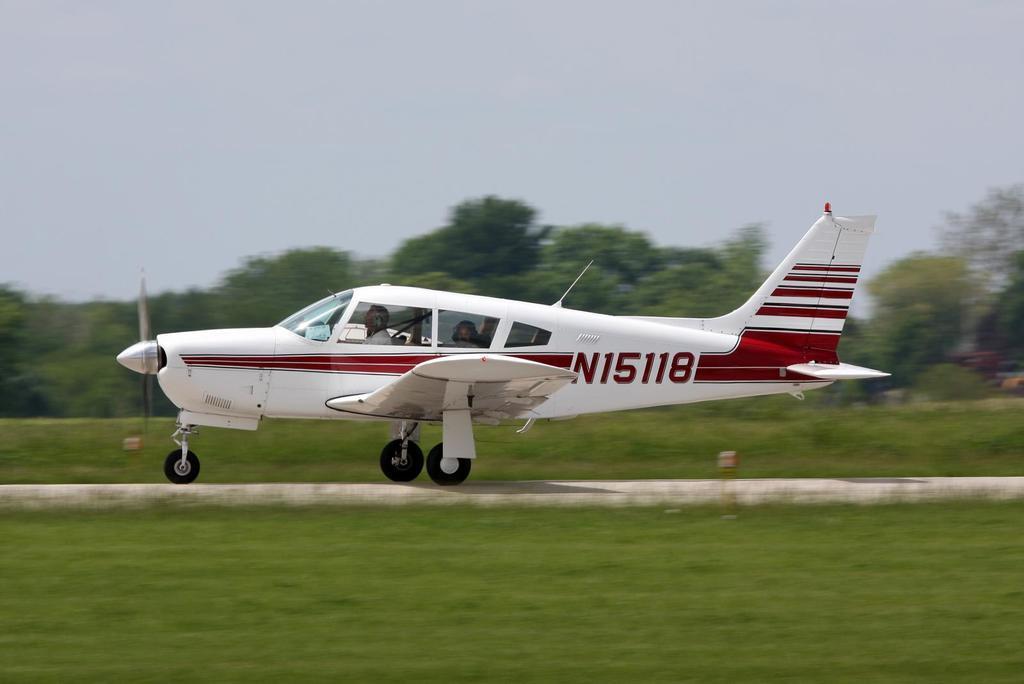In one or two sentences, can you explain what this image depicts? In this image in the center there is an airplane, in the airplane there are some persons. At the bottom there is grass and walkway, in the background there are some trees and at the top of the image there is sky. 